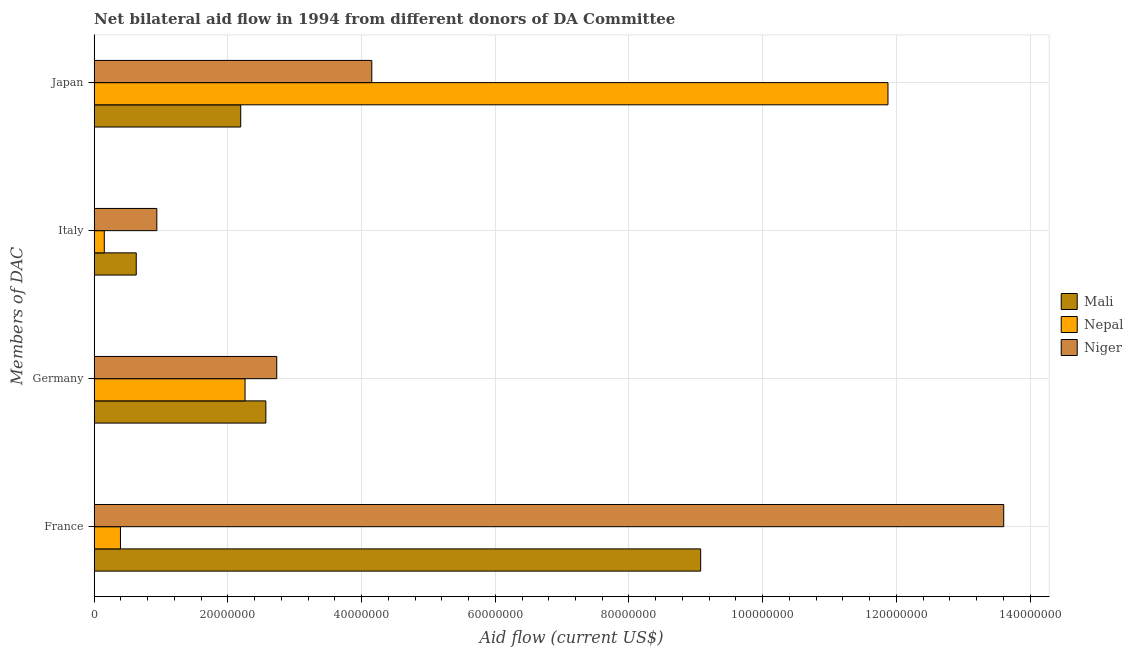How many different coloured bars are there?
Ensure brevity in your answer.  3. Are the number of bars per tick equal to the number of legend labels?
Your response must be concise. Yes. Are the number of bars on each tick of the Y-axis equal?
Offer a very short reply. Yes. How many bars are there on the 4th tick from the bottom?
Your answer should be compact. 3. What is the amount of aid given by germany in Nepal?
Keep it short and to the point. 2.26e+07. Across all countries, what is the maximum amount of aid given by germany?
Offer a very short reply. 2.73e+07. Across all countries, what is the minimum amount of aid given by france?
Your answer should be very brief. 3.93e+06. In which country was the amount of aid given by france maximum?
Provide a succinct answer. Niger. In which country was the amount of aid given by italy minimum?
Ensure brevity in your answer.  Nepal. What is the total amount of aid given by italy in the graph?
Keep it short and to the point. 1.72e+07. What is the difference between the amount of aid given by germany in Mali and that in Niger?
Keep it short and to the point. -1.63e+06. What is the difference between the amount of aid given by france in Mali and the amount of aid given by italy in Niger?
Offer a terse response. 8.14e+07. What is the average amount of aid given by france per country?
Make the answer very short. 7.69e+07. What is the difference between the amount of aid given by germany and amount of aid given by france in Nepal?
Offer a terse response. 1.86e+07. What is the ratio of the amount of aid given by germany in Nepal to that in Mali?
Provide a succinct answer. 0.88. Is the amount of aid given by germany in Nepal less than that in Mali?
Ensure brevity in your answer.  Yes. Is the difference between the amount of aid given by france in Nepal and Niger greater than the difference between the amount of aid given by japan in Nepal and Niger?
Offer a terse response. No. What is the difference between the highest and the second highest amount of aid given by japan?
Make the answer very short. 7.72e+07. What is the difference between the highest and the lowest amount of aid given by japan?
Provide a succinct answer. 9.68e+07. What does the 2nd bar from the top in France represents?
Offer a terse response. Nepal. What does the 2nd bar from the bottom in Japan represents?
Ensure brevity in your answer.  Nepal. Is it the case that in every country, the sum of the amount of aid given by france and amount of aid given by germany is greater than the amount of aid given by italy?
Provide a short and direct response. Yes. How many bars are there?
Provide a short and direct response. 12. Are all the bars in the graph horizontal?
Ensure brevity in your answer.  Yes. How many countries are there in the graph?
Offer a very short reply. 3. Does the graph contain grids?
Give a very brief answer. Yes. What is the title of the graph?
Provide a short and direct response. Net bilateral aid flow in 1994 from different donors of DA Committee. Does "Senegal" appear as one of the legend labels in the graph?
Provide a succinct answer. No. What is the label or title of the X-axis?
Keep it short and to the point. Aid flow (current US$). What is the label or title of the Y-axis?
Provide a short and direct response. Members of DAC. What is the Aid flow (current US$) in Mali in France?
Provide a succinct answer. 9.07e+07. What is the Aid flow (current US$) of Nepal in France?
Provide a short and direct response. 3.93e+06. What is the Aid flow (current US$) in Niger in France?
Offer a terse response. 1.36e+08. What is the Aid flow (current US$) in Mali in Germany?
Ensure brevity in your answer.  2.57e+07. What is the Aid flow (current US$) of Nepal in Germany?
Provide a short and direct response. 2.26e+07. What is the Aid flow (current US$) in Niger in Germany?
Offer a very short reply. 2.73e+07. What is the Aid flow (current US$) in Mali in Italy?
Your answer should be very brief. 6.29e+06. What is the Aid flow (current US$) in Nepal in Italy?
Offer a very short reply. 1.51e+06. What is the Aid flow (current US$) in Niger in Italy?
Your response must be concise. 9.37e+06. What is the Aid flow (current US$) of Mali in Japan?
Your answer should be compact. 2.19e+07. What is the Aid flow (current US$) in Nepal in Japan?
Provide a succinct answer. 1.19e+08. What is the Aid flow (current US$) of Niger in Japan?
Provide a succinct answer. 4.15e+07. Across all Members of DAC, what is the maximum Aid flow (current US$) of Mali?
Give a very brief answer. 9.07e+07. Across all Members of DAC, what is the maximum Aid flow (current US$) of Nepal?
Offer a terse response. 1.19e+08. Across all Members of DAC, what is the maximum Aid flow (current US$) in Niger?
Give a very brief answer. 1.36e+08. Across all Members of DAC, what is the minimum Aid flow (current US$) of Mali?
Ensure brevity in your answer.  6.29e+06. Across all Members of DAC, what is the minimum Aid flow (current US$) of Nepal?
Ensure brevity in your answer.  1.51e+06. Across all Members of DAC, what is the minimum Aid flow (current US$) in Niger?
Offer a very short reply. 9.37e+06. What is the total Aid flow (current US$) in Mali in the graph?
Offer a very short reply. 1.45e+08. What is the total Aid flow (current US$) in Nepal in the graph?
Offer a very short reply. 1.47e+08. What is the total Aid flow (current US$) in Niger in the graph?
Make the answer very short. 2.14e+08. What is the difference between the Aid flow (current US$) in Mali in France and that in Germany?
Your answer should be very brief. 6.50e+07. What is the difference between the Aid flow (current US$) of Nepal in France and that in Germany?
Offer a terse response. -1.86e+07. What is the difference between the Aid flow (current US$) of Niger in France and that in Germany?
Provide a short and direct response. 1.09e+08. What is the difference between the Aid flow (current US$) in Mali in France and that in Italy?
Provide a succinct answer. 8.44e+07. What is the difference between the Aid flow (current US$) of Nepal in France and that in Italy?
Your response must be concise. 2.42e+06. What is the difference between the Aid flow (current US$) in Niger in France and that in Italy?
Your answer should be compact. 1.27e+08. What is the difference between the Aid flow (current US$) of Mali in France and that in Japan?
Make the answer very short. 6.88e+07. What is the difference between the Aid flow (current US$) of Nepal in France and that in Japan?
Offer a very short reply. -1.15e+08. What is the difference between the Aid flow (current US$) in Niger in France and that in Japan?
Your answer should be compact. 9.45e+07. What is the difference between the Aid flow (current US$) in Mali in Germany and that in Italy?
Provide a short and direct response. 1.94e+07. What is the difference between the Aid flow (current US$) in Nepal in Germany and that in Italy?
Your answer should be very brief. 2.11e+07. What is the difference between the Aid flow (current US$) in Niger in Germany and that in Italy?
Give a very brief answer. 1.79e+07. What is the difference between the Aid flow (current US$) in Mali in Germany and that in Japan?
Provide a short and direct response. 3.76e+06. What is the difference between the Aid flow (current US$) of Nepal in Germany and that in Japan?
Keep it short and to the point. -9.62e+07. What is the difference between the Aid flow (current US$) of Niger in Germany and that in Japan?
Provide a short and direct response. -1.42e+07. What is the difference between the Aid flow (current US$) of Mali in Italy and that in Japan?
Your response must be concise. -1.56e+07. What is the difference between the Aid flow (current US$) of Nepal in Italy and that in Japan?
Ensure brevity in your answer.  -1.17e+08. What is the difference between the Aid flow (current US$) in Niger in Italy and that in Japan?
Give a very brief answer. -3.22e+07. What is the difference between the Aid flow (current US$) of Mali in France and the Aid flow (current US$) of Nepal in Germany?
Provide a short and direct response. 6.82e+07. What is the difference between the Aid flow (current US$) of Mali in France and the Aid flow (current US$) of Niger in Germany?
Keep it short and to the point. 6.34e+07. What is the difference between the Aid flow (current US$) of Nepal in France and the Aid flow (current US$) of Niger in Germany?
Offer a terse response. -2.34e+07. What is the difference between the Aid flow (current US$) of Mali in France and the Aid flow (current US$) of Nepal in Italy?
Your answer should be very brief. 8.92e+07. What is the difference between the Aid flow (current US$) in Mali in France and the Aid flow (current US$) in Niger in Italy?
Your answer should be very brief. 8.14e+07. What is the difference between the Aid flow (current US$) in Nepal in France and the Aid flow (current US$) in Niger in Italy?
Make the answer very short. -5.44e+06. What is the difference between the Aid flow (current US$) in Mali in France and the Aid flow (current US$) in Nepal in Japan?
Offer a terse response. -2.80e+07. What is the difference between the Aid flow (current US$) of Mali in France and the Aid flow (current US$) of Niger in Japan?
Your answer should be compact. 4.92e+07. What is the difference between the Aid flow (current US$) of Nepal in France and the Aid flow (current US$) of Niger in Japan?
Offer a terse response. -3.76e+07. What is the difference between the Aid flow (current US$) of Mali in Germany and the Aid flow (current US$) of Nepal in Italy?
Give a very brief answer. 2.42e+07. What is the difference between the Aid flow (current US$) in Mali in Germany and the Aid flow (current US$) in Niger in Italy?
Give a very brief answer. 1.63e+07. What is the difference between the Aid flow (current US$) in Nepal in Germany and the Aid flow (current US$) in Niger in Italy?
Your response must be concise. 1.32e+07. What is the difference between the Aid flow (current US$) in Mali in Germany and the Aid flow (current US$) in Nepal in Japan?
Your response must be concise. -9.31e+07. What is the difference between the Aid flow (current US$) in Mali in Germany and the Aid flow (current US$) in Niger in Japan?
Your answer should be very brief. -1.58e+07. What is the difference between the Aid flow (current US$) of Nepal in Germany and the Aid flow (current US$) of Niger in Japan?
Offer a terse response. -1.90e+07. What is the difference between the Aid flow (current US$) in Mali in Italy and the Aid flow (current US$) in Nepal in Japan?
Make the answer very short. -1.12e+08. What is the difference between the Aid flow (current US$) of Mali in Italy and the Aid flow (current US$) of Niger in Japan?
Keep it short and to the point. -3.52e+07. What is the difference between the Aid flow (current US$) in Nepal in Italy and the Aid flow (current US$) in Niger in Japan?
Give a very brief answer. -4.00e+07. What is the average Aid flow (current US$) in Mali per Members of DAC?
Offer a terse response. 3.62e+07. What is the average Aid flow (current US$) in Nepal per Members of DAC?
Offer a terse response. 3.67e+07. What is the average Aid flow (current US$) of Niger per Members of DAC?
Provide a short and direct response. 5.36e+07. What is the difference between the Aid flow (current US$) of Mali and Aid flow (current US$) of Nepal in France?
Offer a terse response. 8.68e+07. What is the difference between the Aid flow (current US$) in Mali and Aid flow (current US$) in Niger in France?
Give a very brief answer. -4.53e+07. What is the difference between the Aid flow (current US$) in Nepal and Aid flow (current US$) in Niger in France?
Your response must be concise. -1.32e+08. What is the difference between the Aid flow (current US$) of Mali and Aid flow (current US$) of Nepal in Germany?
Offer a terse response. 3.11e+06. What is the difference between the Aid flow (current US$) of Mali and Aid flow (current US$) of Niger in Germany?
Provide a succinct answer. -1.63e+06. What is the difference between the Aid flow (current US$) in Nepal and Aid flow (current US$) in Niger in Germany?
Give a very brief answer. -4.74e+06. What is the difference between the Aid flow (current US$) of Mali and Aid flow (current US$) of Nepal in Italy?
Provide a succinct answer. 4.78e+06. What is the difference between the Aid flow (current US$) of Mali and Aid flow (current US$) of Niger in Italy?
Ensure brevity in your answer.  -3.08e+06. What is the difference between the Aid flow (current US$) in Nepal and Aid flow (current US$) in Niger in Italy?
Your answer should be compact. -7.86e+06. What is the difference between the Aid flow (current US$) in Mali and Aid flow (current US$) in Nepal in Japan?
Provide a short and direct response. -9.68e+07. What is the difference between the Aid flow (current US$) of Mali and Aid flow (current US$) of Niger in Japan?
Keep it short and to the point. -1.96e+07. What is the difference between the Aid flow (current US$) of Nepal and Aid flow (current US$) of Niger in Japan?
Give a very brief answer. 7.72e+07. What is the ratio of the Aid flow (current US$) in Mali in France to that in Germany?
Your answer should be very brief. 3.53. What is the ratio of the Aid flow (current US$) in Nepal in France to that in Germany?
Ensure brevity in your answer.  0.17. What is the ratio of the Aid flow (current US$) in Niger in France to that in Germany?
Provide a succinct answer. 4.98. What is the ratio of the Aid flow (current US$) of Mali in France to that in Italy?
Keep it short and to the point. 14.42. What is the ratio of the Aid flow (current US$) of Nepal in France to that in Italy?
Give a very brief answer. 2.6. What is the ratio of the Aid flow (current US$) of Niger in France to that in Italy?
Give a very brief answer. 14.52. What is the ratio of the Aid flow (current US$) of Mali in France to that in Japan?
Make the answer very short. 4.14. What is the ratio of the Aid flow (current US$) of Nepal in France to that in Japan?
Your answer should be very brief. 0.03. What is the ratio of the Aid flow (current US$) in Niger in France to that in Japan?
Your answer should be compact. 3.28. What is the ratio of the Aid flow (current US$) in Mali in Germany to that in Italy?
Your answer should be very brief. 4.08. What is the ratio of the Aid flow (current US$) in Nepal in Germany to that in Italy?
Give a very brief answer. 14.95. What is the ratio of the Aid flow (current US$) of Niger in Germany to that in Italy?
Your answer should be very brief. 2.91. What is the ratio of the Aid flow (current US$) in Mali in Germany to that in Japan?
Your answer should be compact. 1.17. What is the ratio of the Aid flow (current US$) of Nepal in Germany to that in Japan?
Provide a short and direct response. 0.19. What is the ratio of the Aid flow (current US$) in Niger in Germany to that in Japan?
Provide a succinct answer. 0.66. What is the ratio of the Aid flow (current US$) of Mali in Italy to that in Japan?
Offer a terse response. 0.29. What is the ratio of the Aid flow (current US$) of Nepal in Italy to that in Japan?
Make the answer very short. 0.01. What is the ratio of the Aid flow (current US$) in Niger in Italy to that in Japan?
Your response must be concise. 0.23. What is the difference between the highest and the second highest Aid flow (current US$) in Mali?
Provide a short and direct response. 6.50e+07. What is the difference between the highest and the second highest Aid flow (current US$) in Nepal?
Provide a succinct answer. 9.62e+07. What is the difference between the highest and the second highest Aid flow (current US$) in Niger?
Give a very brief answer. 9.45e+07. What is the difference between the highest and the lowest Aid flow (current US$) of Mali?
Provide a succinct answer. 8.44e+07. What is the difference between the highest and the lowest Aid flow (current US$) in Nepal?
Ensure brevity in your answer.  1.17e+08. What is the difference between the highest and the lowest Aid flow (current US$) in Niger?
Your answer should be compact. 1.27e+08. 